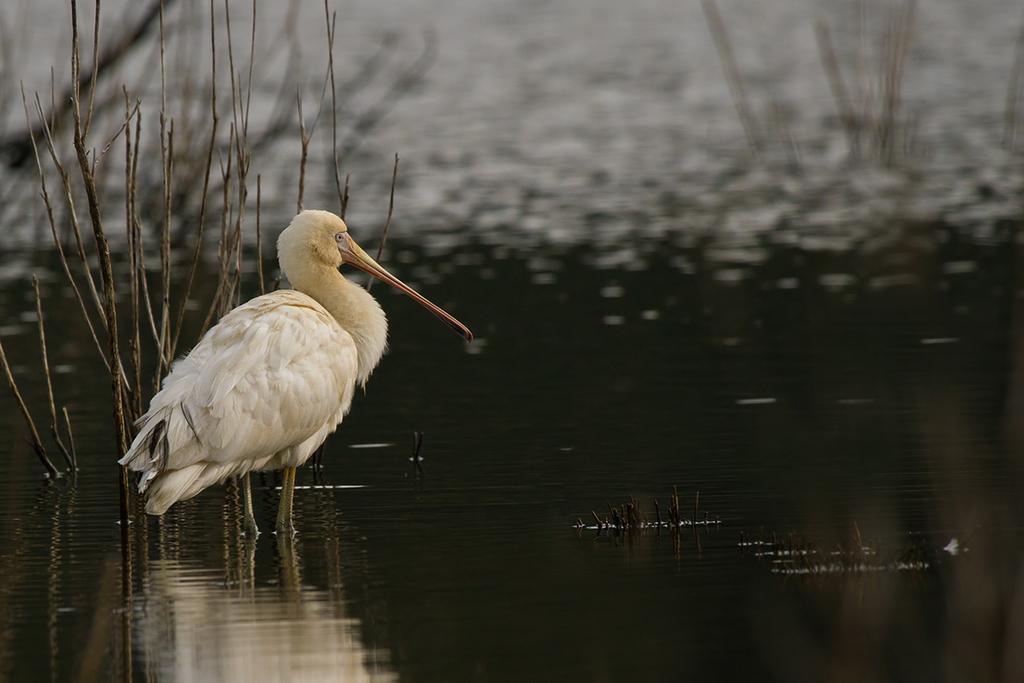Can you describe this image briefly? In this picture there is a white color crane standing in the water pound. Behind there is a dry plant and water in the background. 